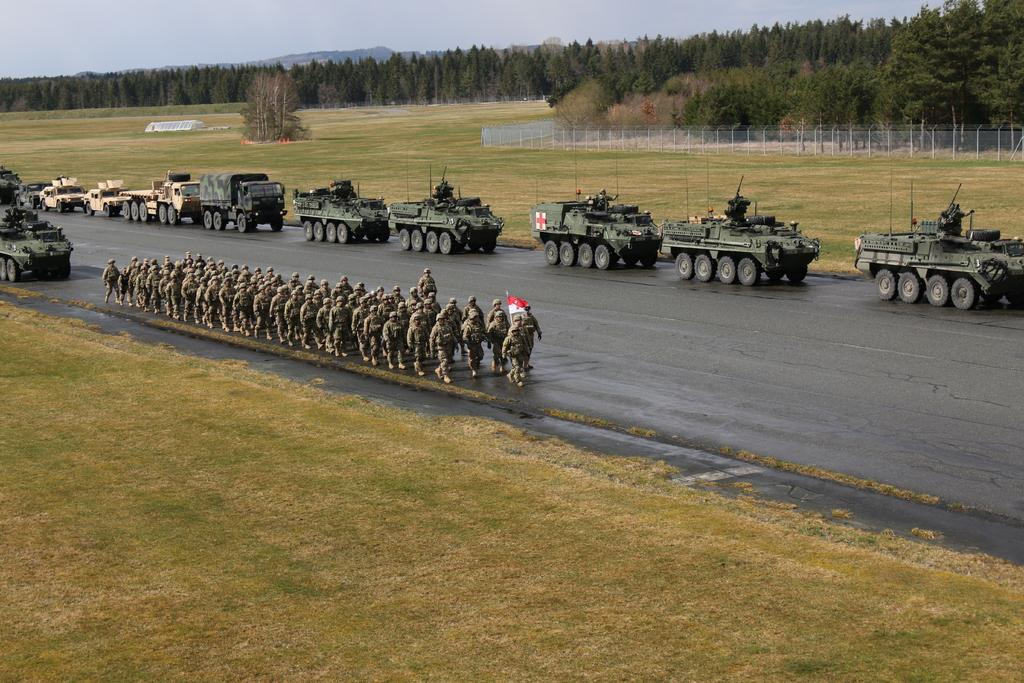What can be seen on the road in the image? There are vehicles and people on the road in the image. What type of vegetation is visible in the image? There is grass visible in the image, and there are trees far from the road. What is the purpose of the fence in the image? The fence is far from the road, and its purpose cannot be determined from the image. How many boys and girls are playing in the park in the image? There is no park, boys, or girls present in the image. 